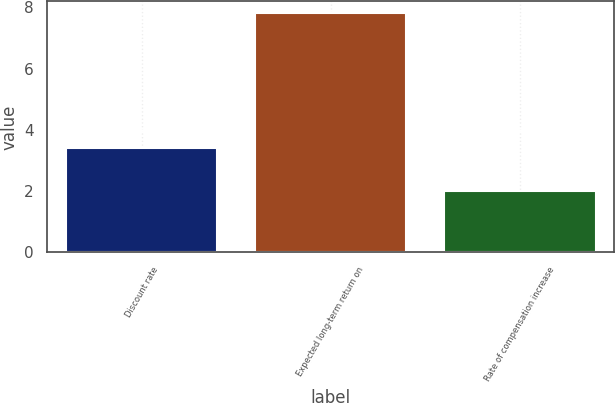Convert chart to OTSL. <chart><loc_0><loc_0><loc_500><loc_500><bar_chart><fcel>Discount rate<fcel>Expected long-term return on<fcel>Rate of compensation increase<nl><fcel>3.4<fcel>7.8<fcel>2<nl></chart> 